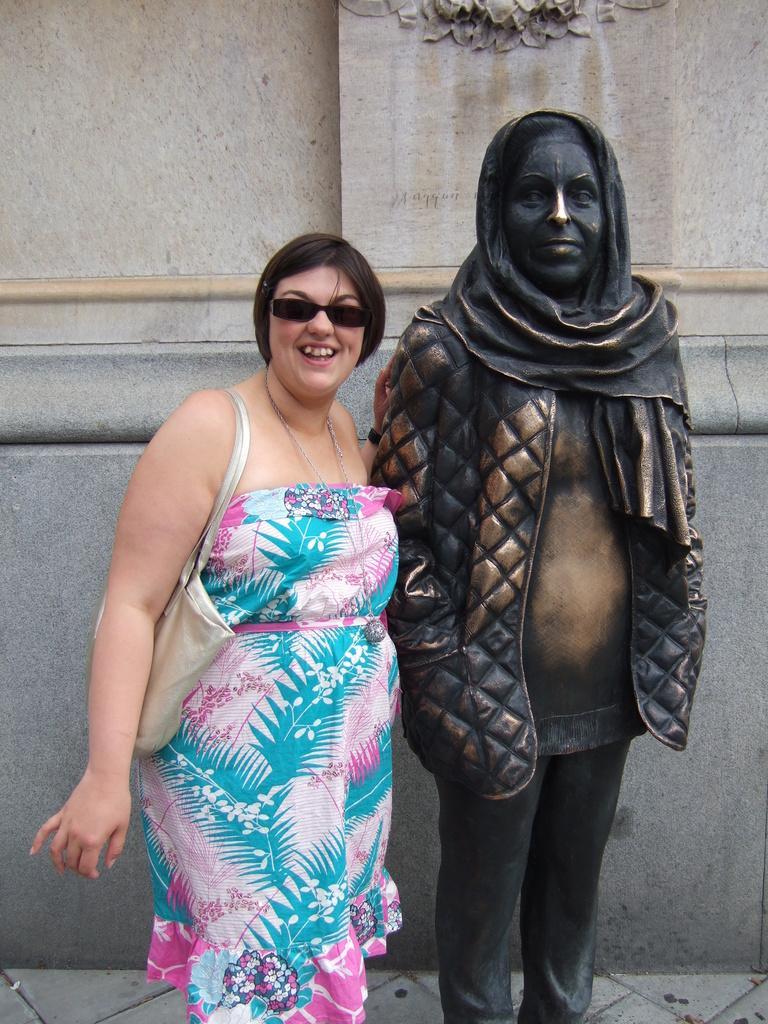Please provide a concise description of this image. In the center of the image a lady is standing and wearing big, goggles. On the right side of the image a statue is there. In the background of the image we can see the wall. At the bottom of the image we can see the ground. 